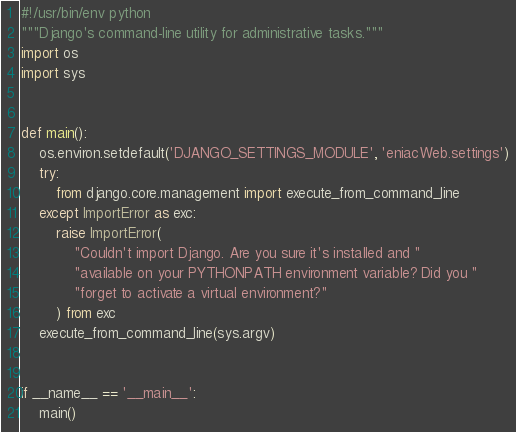Convert code to text. <code><loc_0><loc_0><loc_500><loc_500><_Python_>#!/usr/bin/env python
"""Django's command-line utility for administrative tasks."""
import os
import sys


def main():
    os.environ.setdefault('DJANGO_SETTINGS_MODULE', 'eniacWeb.settings')
    try:
        from django.core.management import execute_from_command_line
    except ImportError as exc:
        raise ImportError(
            "Couldn't import Django. Are you sure it's installed and "
            "available on your PYTHONPATH environment variable? Did you "
            "forget to activate a virtual environment?"
        ) from exc
    execute_from_command_line(sys.argv)


if __name__ == '__main__':
    main()
</code> 